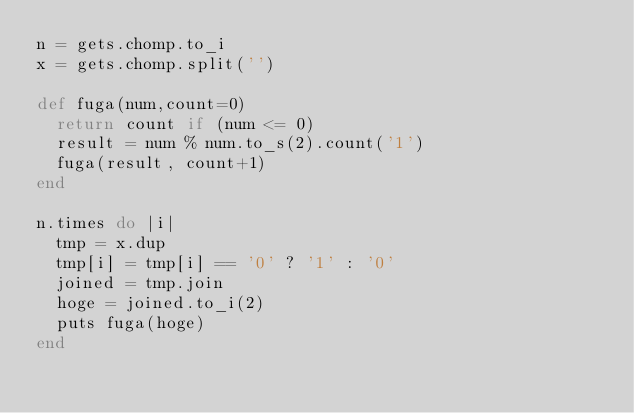<code> <loc_0><loc_0><loc_500><loc_500><_Ruby_>n = gets.chomp.to_i
x = gets.chomp.split('')

def fuga(num,count=0)
  return count if (num <= 0)
  result = num % num.to_s(2).count('1')
  fuga(result, count+1)
end

n.times do |i|
  tmp = x.dup
  tmp[i] = tmp[i] == '0' ? '1' : '0'
  joined = tmp.join
  hoge = joined.to_i(2)
  puts fuga(hoge)
end
</code> 